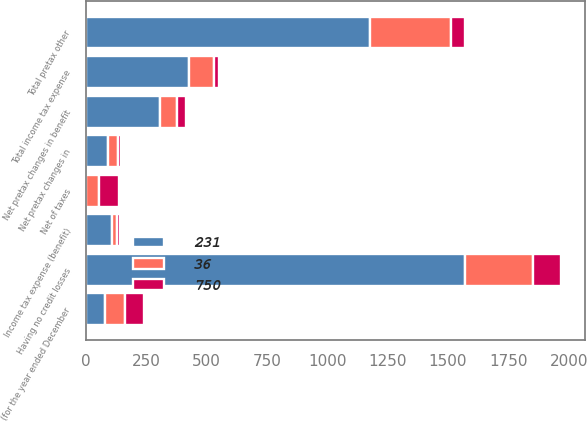Convert chart to OTSL. <chart><loc_0><loc_0><loc_500><loc_500><stacked_bar_chart><ecel><fcel>(for the year ended December<fcel>Having no credit losses<fcel>Net of taxes<fcel>Net pretax changes in benefit<fcel>Income tax expense (benefit)<fcel>Net pretax changes in<fcel>Total pretax other<fcel>Total income tax expense<nl><fcel>36<fcel>80<fcel>281<fcel>53<fcel>69<fcel>23<fcel>43<fcel>336<fcel>105<nl><fcel>231<fcel>80<fcel>1570<fcel>2<fcel>307<fcel>106<fcel>90<fcel>1177<fcel>427<nl><fcel>750<fcel>80<fcel>118<fcel>80<fcel>39<fcel>12<fcel>12<fcel>56<fcel>20<nl></chart> 